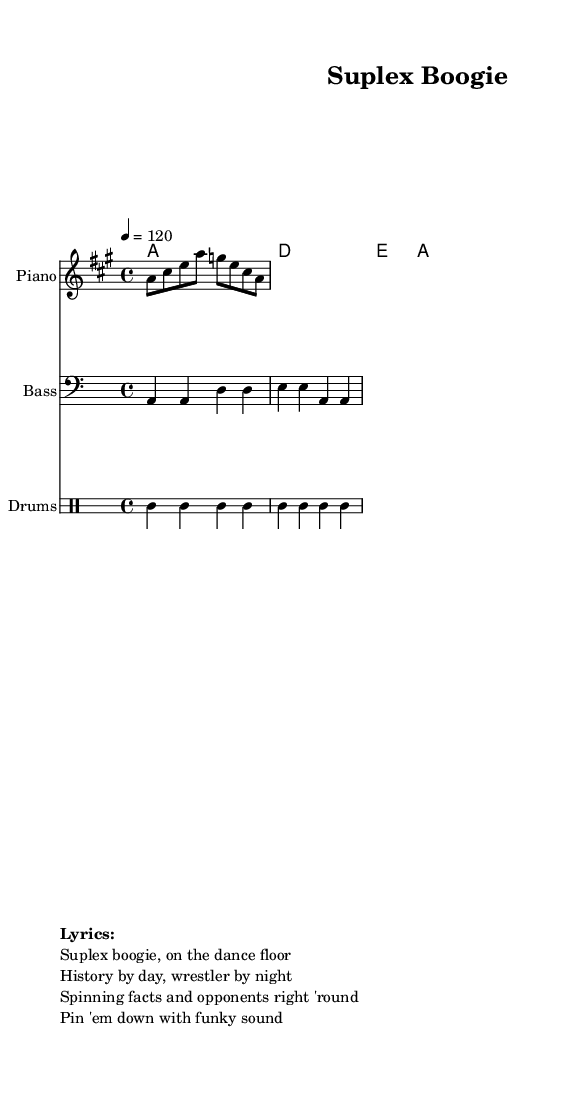What is the key signature of this music? The key signature of the piece is A major, which is indicated by the '#' symbol next to the F note in the key signature section of the sheet music.
Answer: A major What is the time signature of this piece? The time signature of the music is 4/4, which is displayed at the beginning of the sheet music, indicating four beats per measure and a quarter note receiving one beat.
Answer: 4/4 What is the tempo marking of the music? The tempo marking shows "4 = 120", meaning the quarter note is to be played at a speed of 120 beats per minute, as indicated at the start of the score.
Answer: 120 What is the name of this piece? The title "Suplex Boogie" is prominently displayed at the top of the sheet music, making it easy to identify the name of the piece.
Answer: Suplex Boogie How many measures are in the melody? By examining the melody section, we can count a total of eight notes, which corresponds to four measures, indicated by the structure of the notes and their grouping.
Answer: Four What is the main theme of the lyrics in this disco track? The lyrics revolve around the themes of wrestling and history, merging the ideas of physical combat and scholarly pursuit, as reflected in the phrases.
Answer: Wrestling and history What type of musical instrument accompanies the drums in this composition? The sheet music includes both a bass staff and a piano staff, indicating that the bass and piano accompany the rhythmic patterns played on drums.
Answer: Piano and Bass 